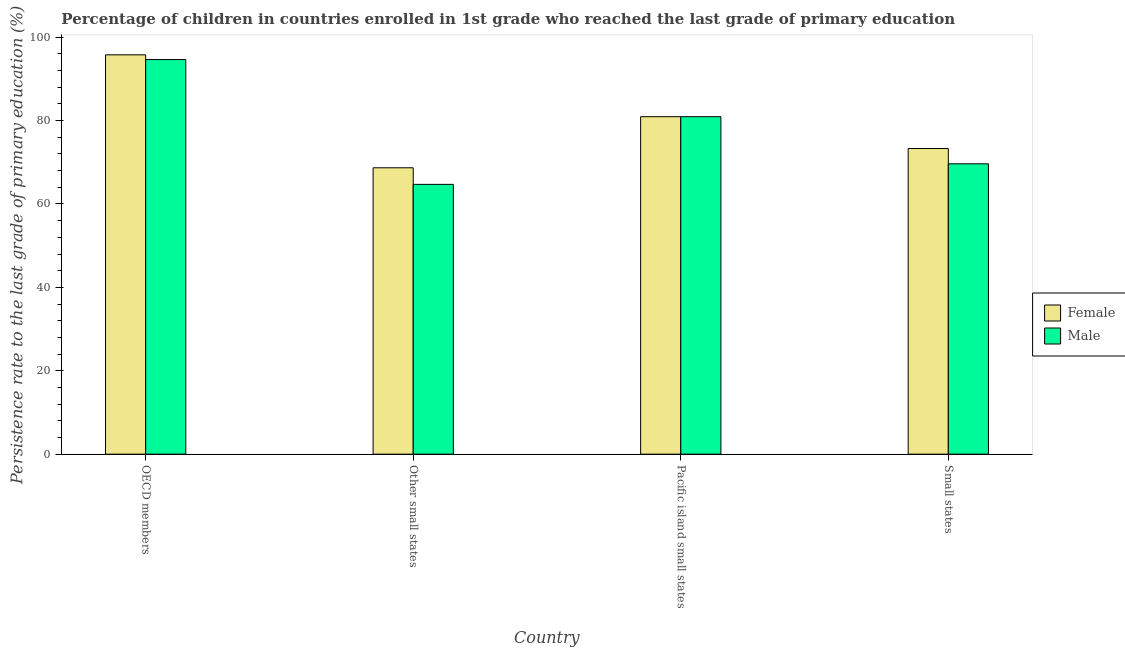Are the number of bars per tick equal to the number of legend labels?
Your response must be concise. Yes. Are the number of bars on each tick of the X-axis equal?
Give a very brief answer. Yes. How many bars are there on the 3rd tick from the right?
Your answer should be very brief. 2. What is the label of the 2nd group of bars from the left?
Your answer should be very brief. Other small states. In how many cases, is the number of bars for a given country not equal to the number of legend labels?
Offer a terse response. 0. What is the persistence rate of female students in Pacific island small states?
Your answer should be compact. 80.93. Across all countries, what is the maximum persistence rate of male students?
Provide a short and direct response. 94.64. Across all countries, what is the minimum persistence rate of male students?
Give a very brief answer. 64.71. In which country was the persistence rate of male students minimum?
Offer a very short reply. Other small states. What is the total persistence rate of male students in the graph?
Provide a short and direct response. 309.92. What is the difference between the persistence rate of male students in Other small states and that in Small states?
Ensure brevity in your answer.  -4.93. What is the difference between the persistence rate of male students in OECD members and the persistence rate of female students in Other small states?
Your answer should be very brief. 25.96. What is the average persistence rate of male students per country?
Provide a succinct answer. 77.48. What is the difference between the persistence rate of female students and persistence rate of male students in Pacific island small states?
Ensure brevity in your answer.  -0. What is the ratio of the persistence rate of male students in Pacific island small states to that in Small states?
Your answer should be very brief. 1.16. Is the difference between the persistence rate of male students in Other small states and Small states greater than the difference between the persistence rate of female students in Other small states and Small states?
Give a very brief answer. No. What is the difference between the highest and the second highest persistence rate of female students?
Provide a succinct answer. 14.84. What is the difference between the highest and the lowest persistence rate of male students?
Provide a short and direct response. 29.93. In how many countries, is the persistence rate of male students greater than the average persistence rate of male students taken over all countries?
Offer a very short reply. 2. Is the sum of the persistence rate of female students in OECD members and Small states greater than the maximum persistence rate of male students across all countries?
Give a very brief answer. Yes. What does the 2nd bar from the left in Other small states represents?
Keep it short and to the point. Male. Are all the bars in the graph horizontal?
Offer a very short reply. No. Are the values on the major ticks of Y-axis written in scientific E-notation?
Make the answer very short. No. Does the graph contain grids?
Your answer should be very brief. No. Where does the legend appear in the graph?
Your response must be concise. Center right. How are the legend labels stacked?
Your answer should be compact. Vertical. What is the title of the graph?
Ensure brevity in your answer.  Percentage of children in countries enrolled in 1st grade who reached the last grade of primary education. What is the label or title of the Y-axis?
Keep it short and to the point. Persistence rate to the last grade of primary education (%). What is the Persistence rate to the last grade of primary education (%) in Female in OECD members?
Keep it short and to the point. 95.77. What is the Persistence rate to the last grade of primary education (%) of Male in OECD members?
Your answer should be compact. 94.64. What is the Persistence rate to the last grade of primary education (%) of Female in Other small states?
Give a very brief answer. 68.68. What is the Persistence rate to the last grade of primary education (%) of Male in Other small states?
Give a very brief answer. 64.71. What is the Persistence rate to the last grade of primary education (%) in Female in Pacific island small states?
Provide a short and direct response. 80.93. What is the Persistence rate to the last grade of primary education (%) in Male in Pacific island small states?
Your answer should be compact. 80.94. What is the Persistence rate to the last grade of primary education (%) of Female in Small states?
Your response must be concise. 73.3. What is the Persistence rate to the last grade of primary education (%) in Male in Small states?
Provide a succinct answer. 69.63. Across all countries, what is the maximum Persistence rate to the last grade of primary education (%) in Female?
Ensure brevity in your answer.  95.77. Across all countries, what is the maximum Persistence rate to the last grade of primary education (%) of Male?
Your answer should be very brief. 94.64. Across all countries, what is the minimum Persistence rate to the last grade of primary education (%) in Female?
Your answer should be very brief. 68.68. Across all countries, what is the minimum Persistence rate to the last grade of primary education (%) of Male?
Provide a succinct answer. 64.71. What is the total Persistence rate to the last grade of primary education (%) in Female in the graph?
Your answer should be very brief. 318.68. What is the total Persistence rate to the last grade of primary education (%) of Male in the graph?
Offer a terse response. 309.92. What is the difference between the Persistence rate to the last grade of primary education (%) in Female in OECD members and that in Other small states?
Make the answer very short. 27.09. What is the difference between the Persistence rate to the last grade of primary education (%) of Male in OECD members and that in Other small states?
Your answer should be compact. 29.93. What is the difference between the Persistence rate to the last grade of primary education (%) of Female in OECD members and that in Pacific island small states?
Make the answer very short. 14.84. What is the difference between the Persistence rate to the last grade of primary education (%) of Male in OECD members and that in Pacific island small states?
Offer a terse response. 13.7. What is the difference between the Persistence rate to the last grade of primary education (%) in Female in OECD members and that in Small states?
Ensure brevity in your answer.  22.47. What is the difference between the Persistence rate to the last grade of primary education (%) in Male in OECD members and that in Small states?
Make the answer very short. 25.01. What is the difference between the Persistence rate to the last grade of primary education (%) of Female in Other small states and that in Pacific island small states?
Your answer should be compact. -12.25. What is the difference between the Persistence rate to the last grade of primary education (%) in Male in Other small states and that in Pacific island small states?
Provide a short and direct response. -16.23. What is the difference between the Persistence rate to the last grade of primary education (%) of Female in Other small states and that in Small states?
Your answer should be compact. -4.62. What is the difference between the Persistence rate to the last grade of primary education (%) of Male in Other small states and that in Small states?
Your response must be concise. -4.93. What is the difference between the Persistence rate to the last grade of primary education (%) in Female in Pacific island small states and that in Small states?
Give a very brief answer. 7.63. What is the difference between the Persistence rate to the last grade of primary education (%) of Male in Pacific island small states and that in Small states?
Make the answer very short. 11.3. What is the difference between the Persistence rate to the last grade of primary education (%) in Female in OECD members and the Persistence rate to the last grade of primary education (%) in Male in Other small states?
Your response must be concise. 31.06. What is the difference between the Persistence rate to the last grade of primary education (%) of Female in OECD members and the Persistence rate to the last grade of primary education (%) of Male in Pacific island small states?
Offer a terse response. 14.83. What is the difference between the Persistence rate to the last grade of primary education (%) in Female in OECD members and the Persistence rate to the last grade of primary education (%) in Male in Small states?
Make the answer very short. 26.14. What is the difference between the Persistence rate to the last grade of primary education (%) in Female in Other small states and the Persistence rate to the last grade of primary education (%) in Male in Pacific island small states?
Offer a very short reply. -12.26. What is the difference between the Persistence rate to the last grade of primary education (%) of Female in Other small states and the Persistence rate to the last grade of primary education (%) of Male in Small states?
Offer a terse response. -0.95. What is the difference between the Persistence rate to the last grade of primary education (%) in Female in Pacific island small states and the Persistence rate to the last grade of primary education (%) in Male in Small states?
Your answer should be compact. 11.3. What is the average Persistence rate to the last grade of primary education (%) in Female per country?
Provide a succinct answer. 79.67. What is the average Persistence rate to the last grade of primary education (%) of Male per country?
Your response must be concise. 77.48. What is the difference between the Persistence rate to the last grade of primary education (%) in Female and Persistence rate to the last grade of primary education (%) in Male in OECD members?
Offer a terse response. 1.13. What is the difference between the Persistence rate to the last grade of primary education (%) of Female and Persistence rate to the last grade of primary education (%) of Male in Other small states?
Provide a succinct answer. 3.97. What is the difference between the Persistence rate to the last grade of primary education (%) of Female and Persistence rate to the last grade of primary education (%) of Male in Pacific island small states?
Your response must be concise. -0. What is the difference between the Persistence rate to the last grade of primary education (%) of Female and Persistence rate to the last grade of primary education (%) of Male in Small states?
Offer a terse response. 3.67. What is the ratio of the Persistence rate to the last grade of primary education (%) in Female in OECD members to that in Other small states?
Your response must be concise. 1.39. What is the ratio of the Persistence rate to the last grade of primary education (%) in Male in OECD members to that in Other small states?
Offer a very short reply. 1.46. What is the ratio of the Persistence rate to the last grade of primary education (%) in Female in OECD members to that in Pacific island small states?
Offer a terse response. 1.18. What is the ratio of the Persistence rate to the last grade of primary education (%) in Male in OECD members to that in Pacific island small states?
Offer a very short reply. 1.17. What is the ratio of the Persistence rate to the last grade of primary education (%) of Female in OECD members to that in Small states?
Offer a terse response. 1.31. What is the ratio of the Persistence rate to the last grade of primary education (%) in Male in OECD members to that in Small states?
Ensure brevity in your answer.  1.36. What is the ratio of the Persistence rate to the last grade of primary education (%) in Female in Other small states to that in Pacific island small states?
Offer a very short reply. 0.85. What is the ratio of the Persistence rate to the last grade of primary education (%) in Male in Other small states to that in Pacific island small states?
Your response must be concise. 0.8. What is the ratio of the Persistence rate to the last grade of primary education (%) of Female in Other small states to that in Small states?
Offer a terse response. 0.94. What is the ratio of the Persistence rate to the last grade of primary education (%) in Male in Other small states to that in Small states?
Make the answer very short. 0.93. What is the ratio of the Persistence rate to the last grade of primary education (%) of Female in Pacific island small states to that in Small states?
Your answer should be very brief. 1.1. What is the ratio of the Persistence rate to the last grade of primary education (%) in Male in Pacific island small states to that in Small states?
Offer a very short reply. 1.16. What is the difference between the highest and the second highest Persistence rate to the last grade of primary education (%) of Female?
Ensure brevity in your answer.  14.84. What is the difference between the highest and the second highest Persistence rate to the last grade of primary education (%) in Male?
Offer a terse response. 13.7. What is the difference between the highest and the lowest Persistence rate to the last grade of primary education (%) in Female?
Ensure brevity in your answer.  27.09. What is the difference between the highest and the lowest Persistence rate to the last grade of primary education (%) in Male?
Provide a short and direct response. 29.93. 